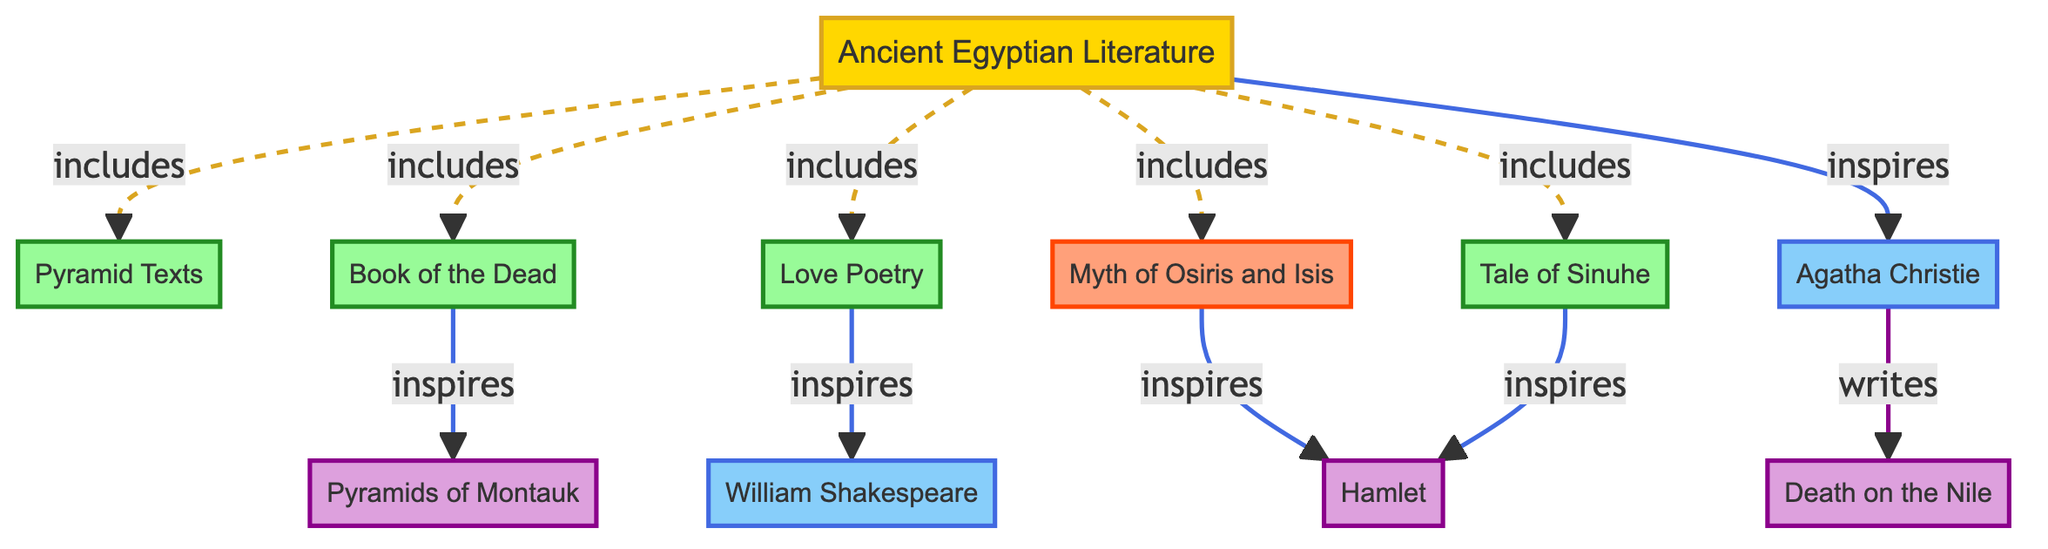What is the source node in the diagram? The source node is the starting point of the network diagram. By examining the diagram, we identify "Ancient Egyptian Literature" as the only node labeled as a source.
Answer: Ancient Egyptian Literature How many literary works are included under Ancient Egyptian Literature? The edges from "Ancient Egyptian Literature" to the literary works show five connections: Pyramid Texts, Book of the Dead, Love Poetry, Myth of Osiris and Isis, and Tale of Sinuhe. Adding these gives a total of five literary works included.
Answer: 5 Which modern author is connected to the Love Poetry node? The edge from "Love Poetry" points towards "William Shakespeare," indicating that he is influenced by it. This is a direct connection as indicated in the diagram.
Answer: William Shakespeare What modern literary work is inspired by the Book of the Dead? According to the edge from "Book of the Dead," it inspires "Pyramids of Montauk," showing a direct influence from this ancient work to the modern literary work.
Answer: Pyramids of Montauk Which ancient literary work inspires the most modern works? The node "Hamlet" has two incoming edges from both "Myth of Osiris and Isis" and "Tale of Sinuhe," indicating that it is inspired by these two different ancient works, making it the one inspired by the most.
Answer: Hamlet How many edges lead to modern authors in the diagram? The edges leading to modern authors include those from "Love Poetry" to "William Shakespeare," and from "Ancient Egyptian Literature" to "Agatha Christie." Counting these connections gives a total of three edges leading to modern authors.
Answer: 3 Which myth is connected to multiple modern works? "Myth of Osiris and Isis" has a direct connection to "Hamlet," which indicates multiple influences. This myth acts as a source of inspiration for a modern literary work and reflects a significant thematic influence in the diagram.
Answer: Myth of Osiris and Isis Which modern literary work is authored by Agatha Christie? The edge shows a direct connection from "Agatha Christie" to "Death on the Nile," confirming that this is the specific modern work she wrote, corresponding with the diagram's flow.
Answer: Death on the Nile 